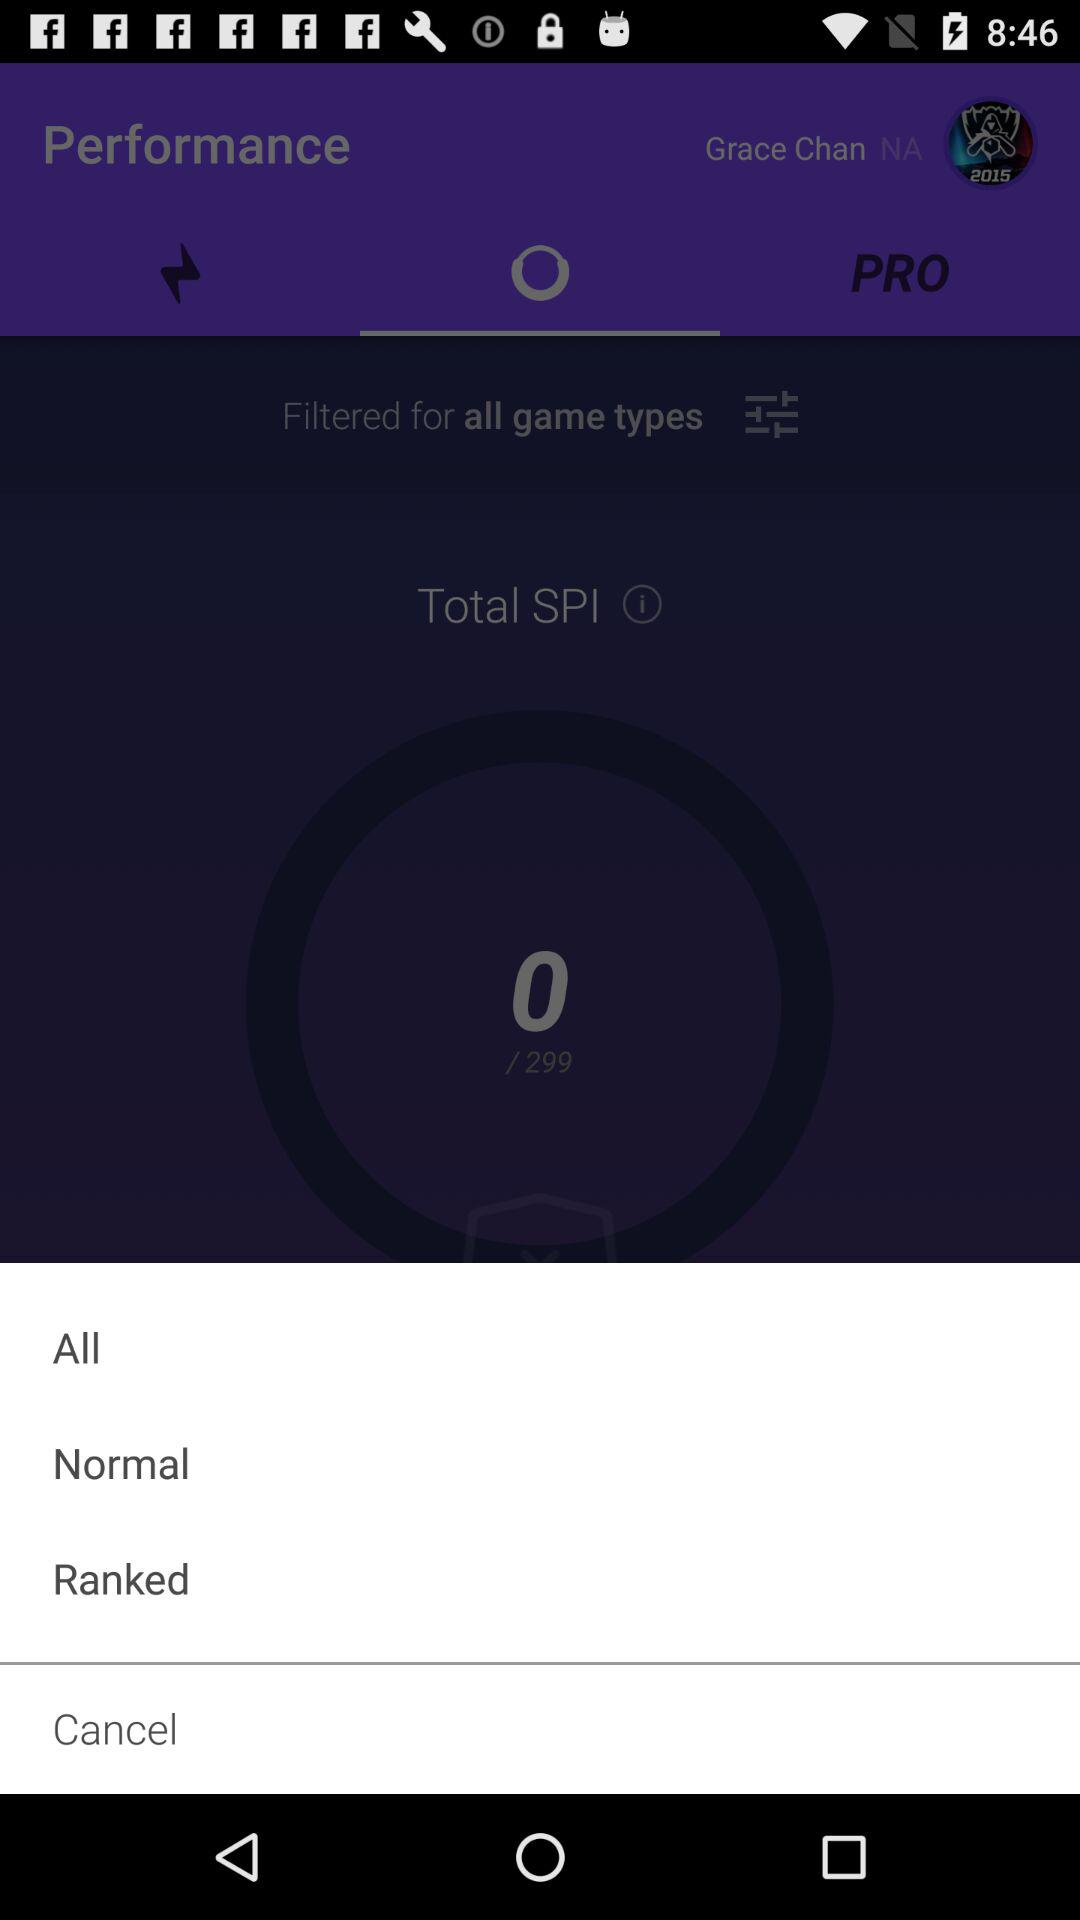How many game types can you filter by?
Answer the question using a single word or phrase. 3 